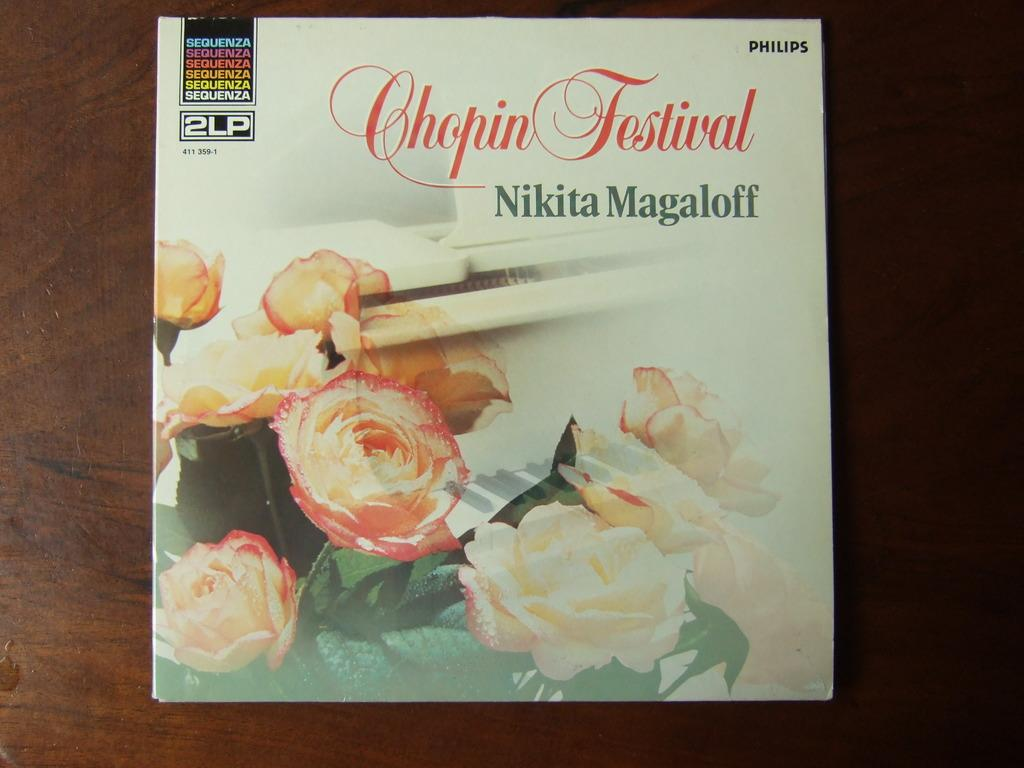What is present on the table in the image? There is a paper placed on a table in the image. Can you describe the paper in the image? The paper is the main object visible on the table. What direction is the soap facing in the image? There is no soap present in the image. Is the pot visible in the image? There is no pot present in the image. 